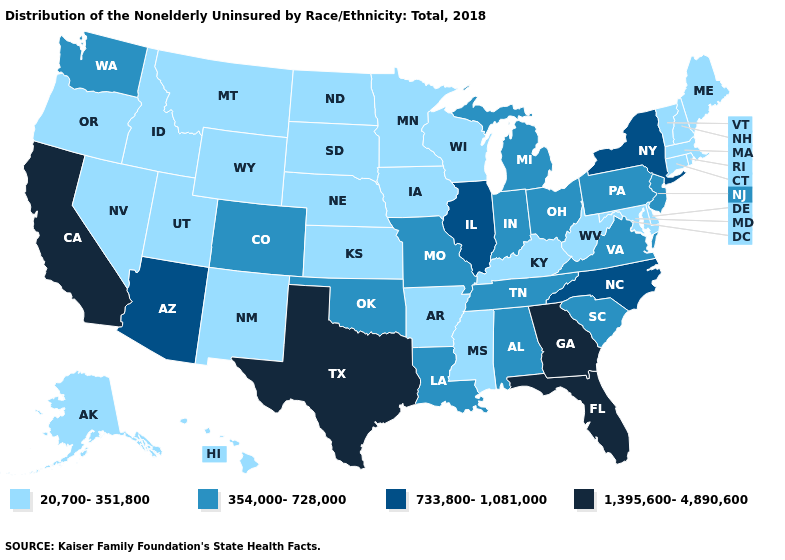Which states hav the highest value in the MidWest?
Write a very short answer. Illinois. Which states have the lowest value in the USA?
Write a very short answer. Alaska, Arkansas, Connecticut, Delaware, Hawaii, Idaho, Iowa, Kansas, Kentucky, Maine, Maryland, Massachusetts, Minnesota, Mississippi, Montana, Nebraska, Nevada, New Hampshire, New Mexico, North Dakota, Oregon, Rhode Island, South Dakota, Utah, Vermont, West Virginia, Wisconsin, Wyoming. What is the value of Wisconsin?
Give a very brief answer. 20,700-351,800. Name the states that have a value in the range 354,000-728,000?
Answer briefly. Alabama, Colorado, Indiana, Louisiana, Michigan, Missouri, New Jersey, Ohio, Oklahoma, Pennsylvania, South Carolina, Tennessee, Virginia, Washington. Does Washington have the lowest value in the USA?
Be succinct. No. Name the states that have a value in the range 354,000-728,000?
Give a very brief answer. Alabama, Colorado, Indiana, Louisiana, Michigan, Missouri, New Jersey, Ohio, Oklahoma, Pennsylvania, South Carolina, Tennessee, Virginia, Washington. What is the lowest value in the USA?
Keep it brief. 20,700-351,800. What is the value of Arkansas?
Answer briefly. 20,700-351,800. Among the states that border Kansas , does Oklahoma have the highest value?
Give a very brief answer. Yes. What is the lowest value in states that border Connecticut?
Concise answer only. 20,700-351,800. What is the highest value in the USA?
Answer briefly. 1,395,600-4,890,600. Name the states that have a value in the range 354,000-728,000?
Keep it brief. Alabama, Colorado, Indiana, Louisiana, Michigan, Missouri, New Jersey, Ohio, Oklahoma, Pennsylvania, South Carolina, Tennessee, Virginia, Washington. Name the states that have a value in the range 354,000-728,000?
Quick response, please. Alabama, Colorado, Indiana, Louisiana, Michigan, Missouri, New Jersey, Ohio, Oklahoma, Pennsylvania, South Carolina, Tennessee, Virginia, Washington. Does South Carolina have the lowest value in the USA?
Answer briefly. No. What is the lowest value in states that border Oklahoma?
Be succinct. 20,700-351,800. 